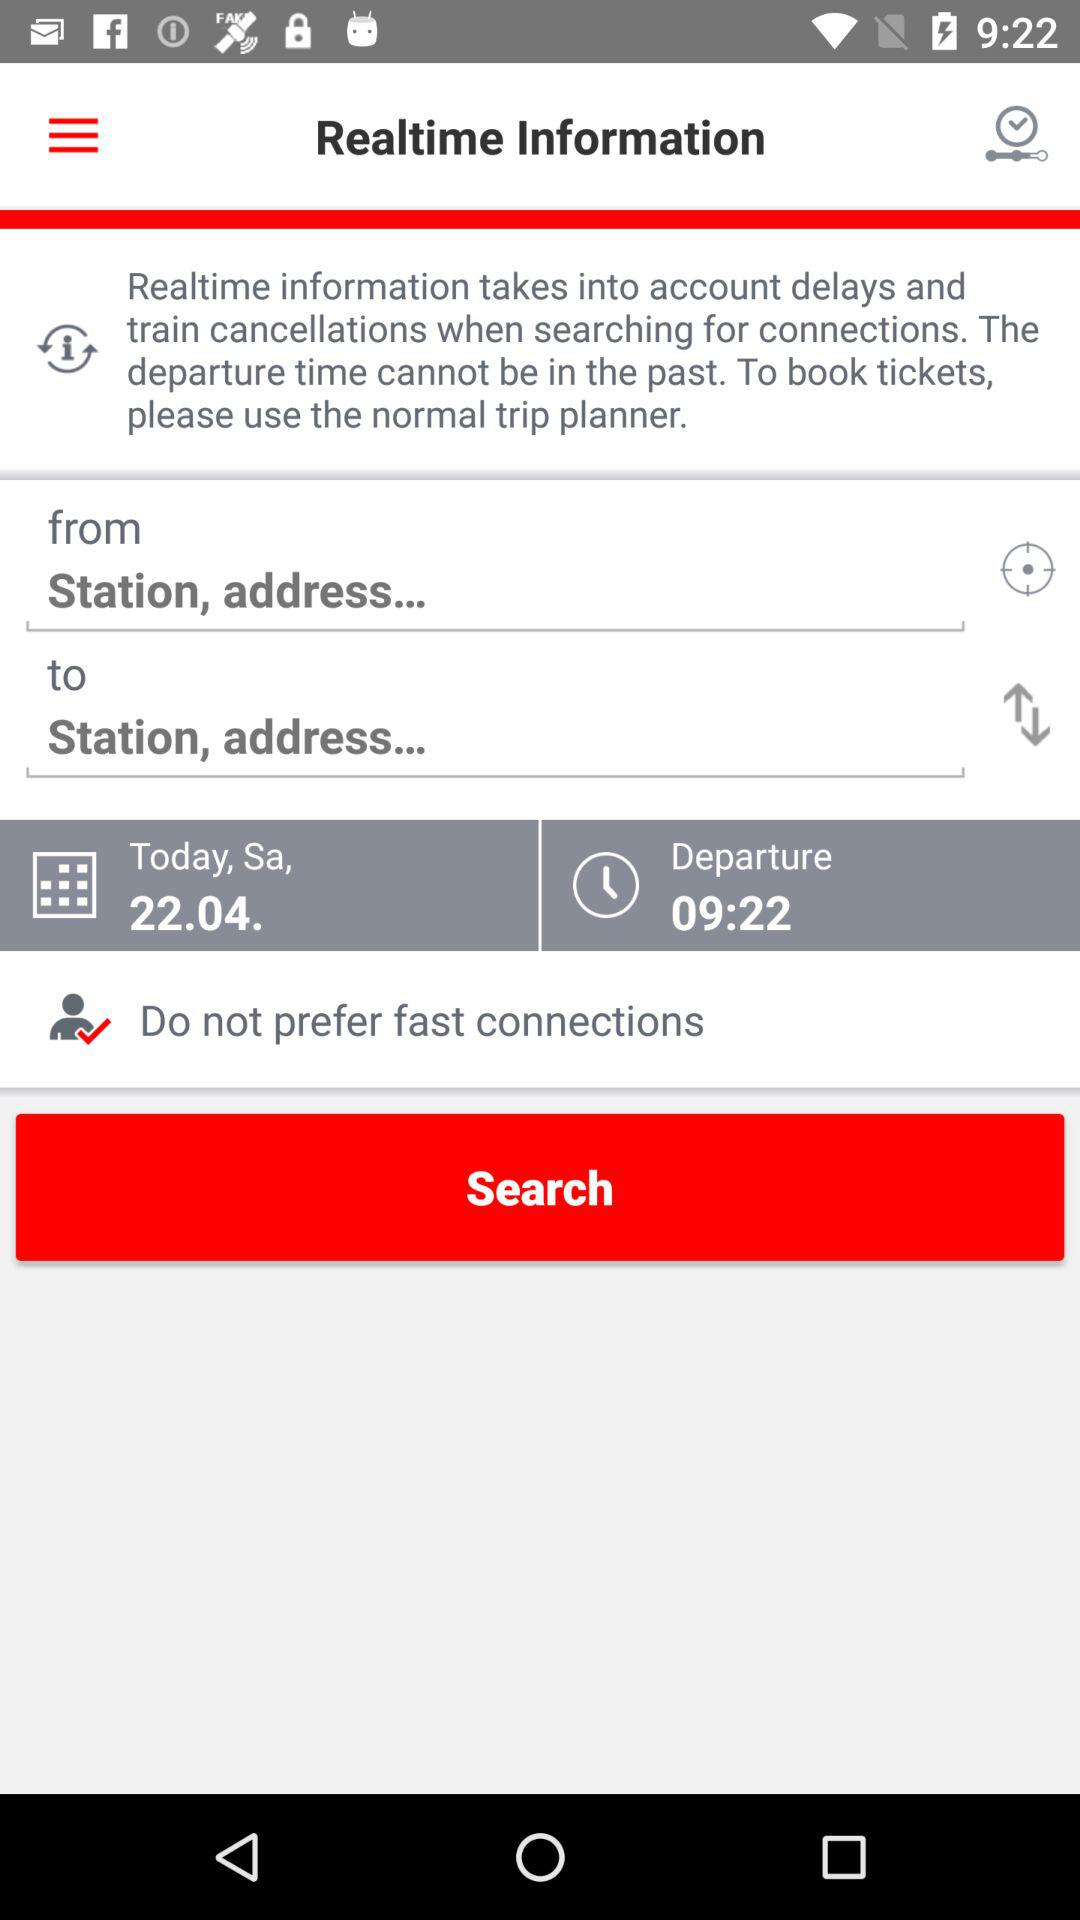What is the departure time? The departure time is 09:22. 